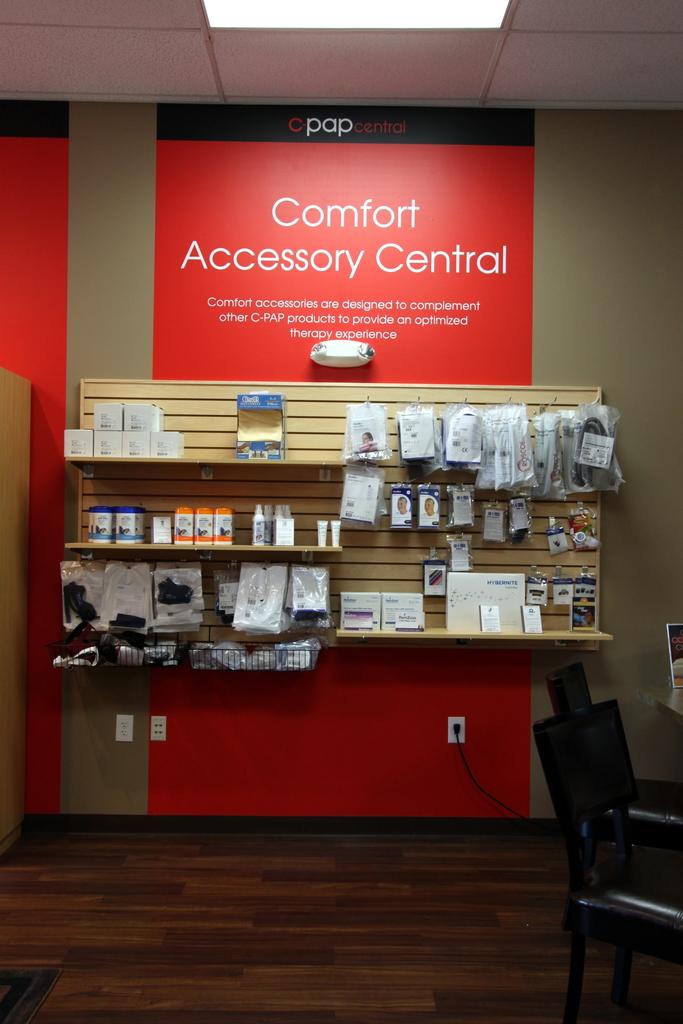What os the word in the black stripe at the top of the sign?
Ensure brevity in your answer.  Pap. 